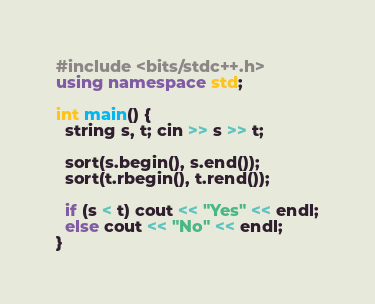<code> <loc_0><loc_0><loc_500><loc_500><_C++_>#include <bits/stdc++.h>
using namespace std;

int main() {
  string s, t; cin >> s >> t;
  
  sort(s.begin(), s.end());
  sort(t.rbegin(), t.rend());
  
  if (s < t) cout << "Yes" << endl;
  else cout << "No" << endl;
}</code> 